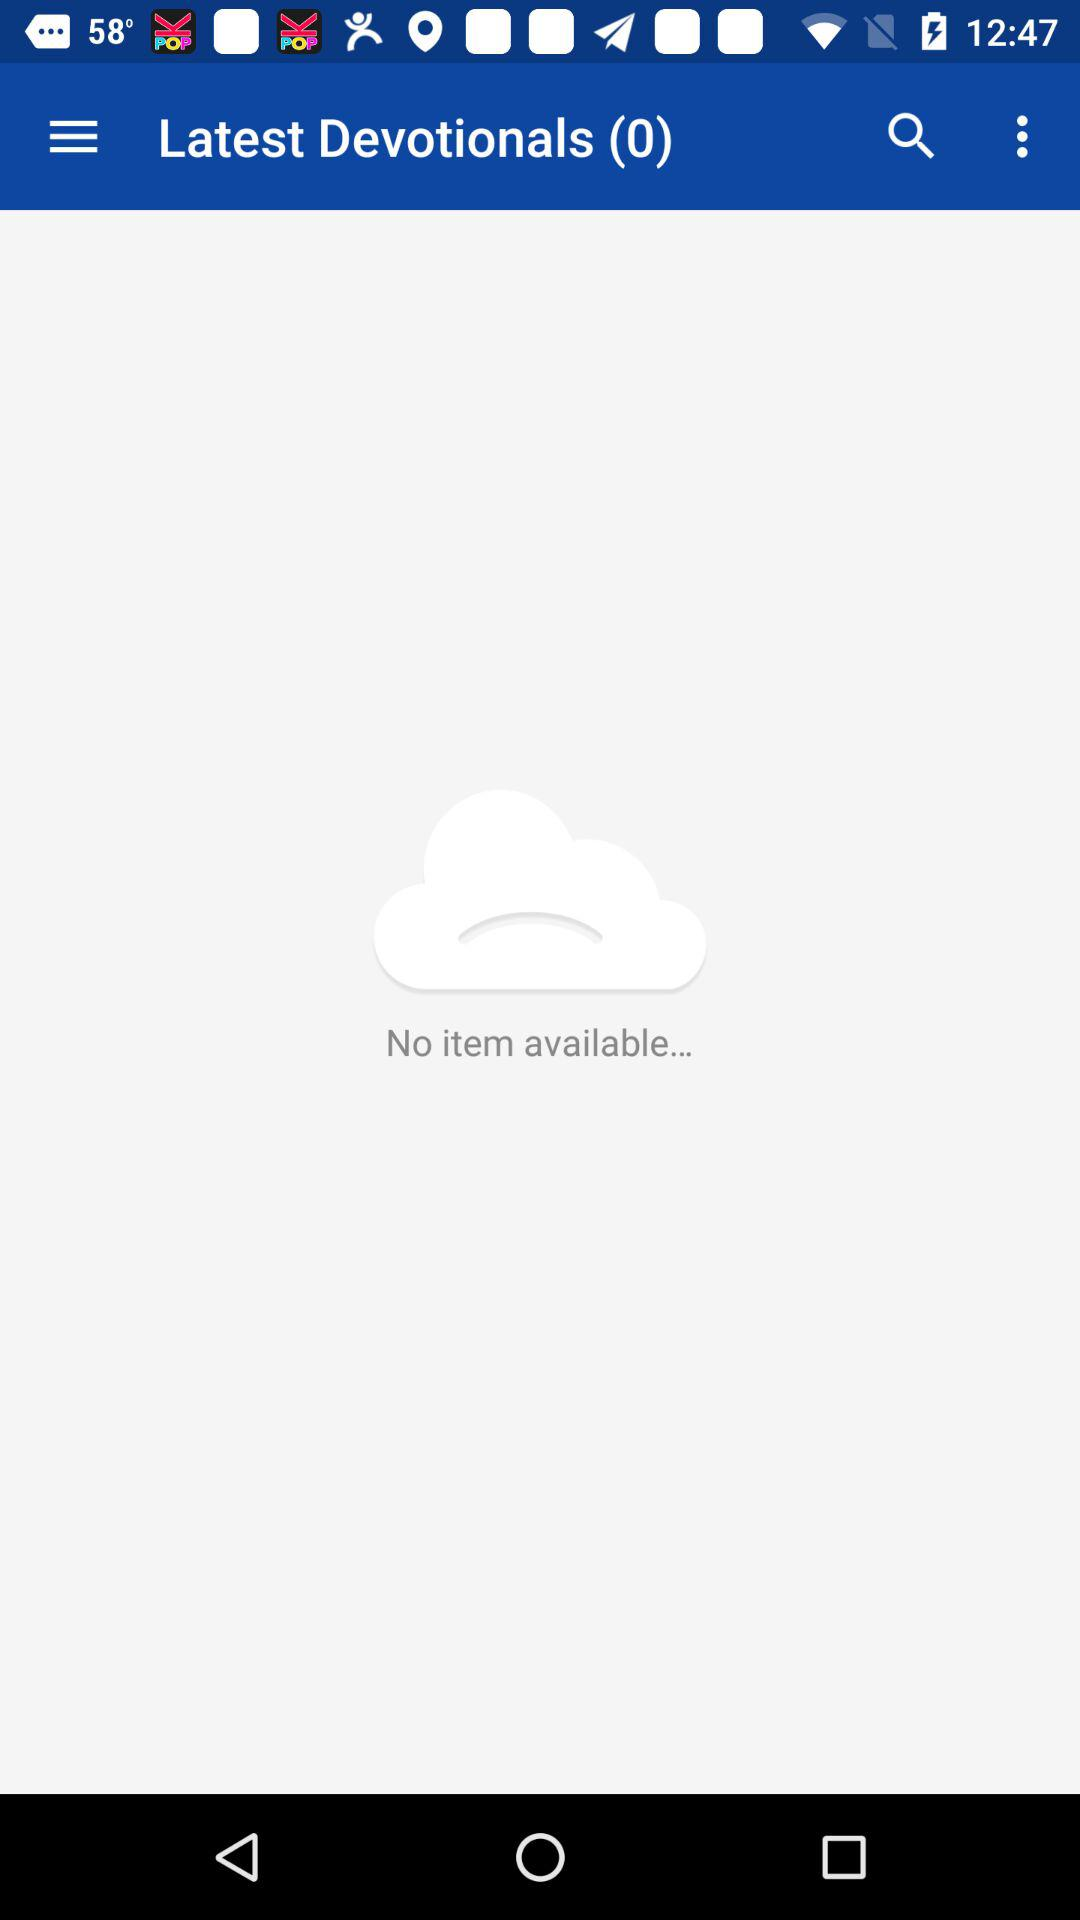How many items are there in the latest devotionals section?
Answer the question using a single word or phrase. 0 